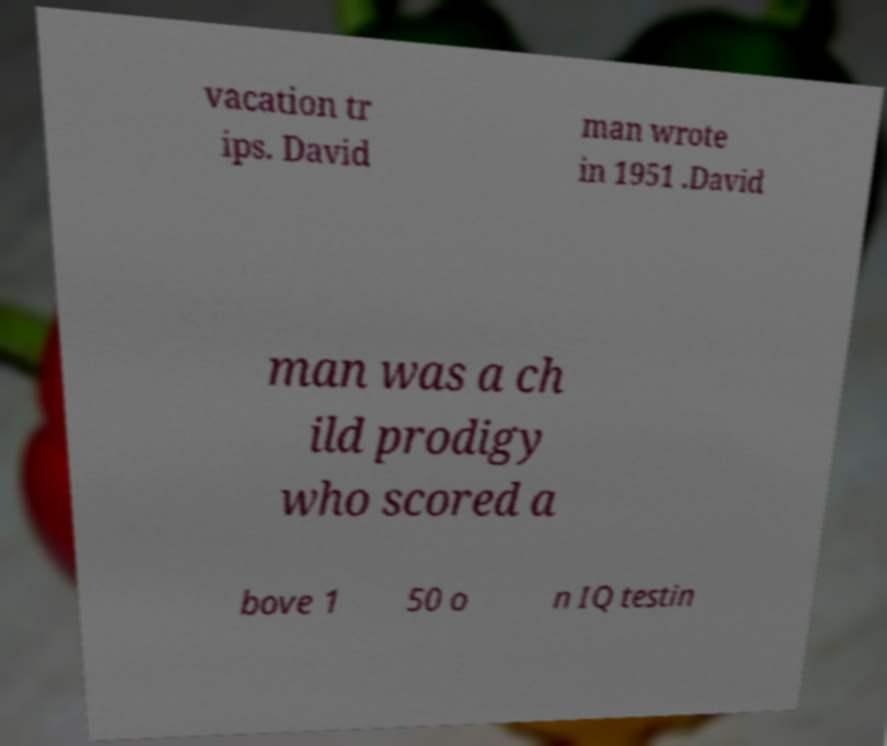Can you accurately transcribe the text from the provided image for me? vacation tr ips. David man wrote in 1951 .David man was a ch ild prodigy who scored a bove 1 50 o n IQ testin 